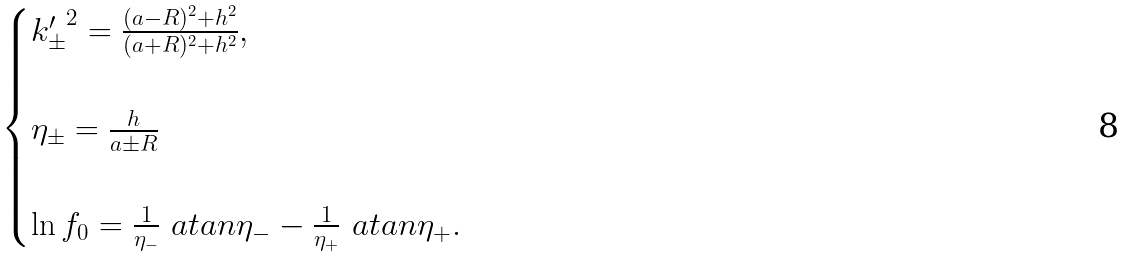Convert formula to latex. <formula><loc_0><loc_0><loc_500><loc_500>\begin{cases} { k ^ { \prime } _ { \pm } } ^ { 2 } = \frac { ( a - R ) ^ { 2 } + h ^ { 2 } } { ( a + R ) ^ { 2 } + h ^ { 2 } } , \\ \\ \eta _ { \pm } = \frac { h } { a \pm R } \\ \\ \ln f _ { 0 } = \frac { 1 } { \eta _ { - } } \ a t a n \eta _ { - } - \frac { 1 } { \eta _ { + } } \ a t a n \eta _ { + } . \end{cases}</formula> 